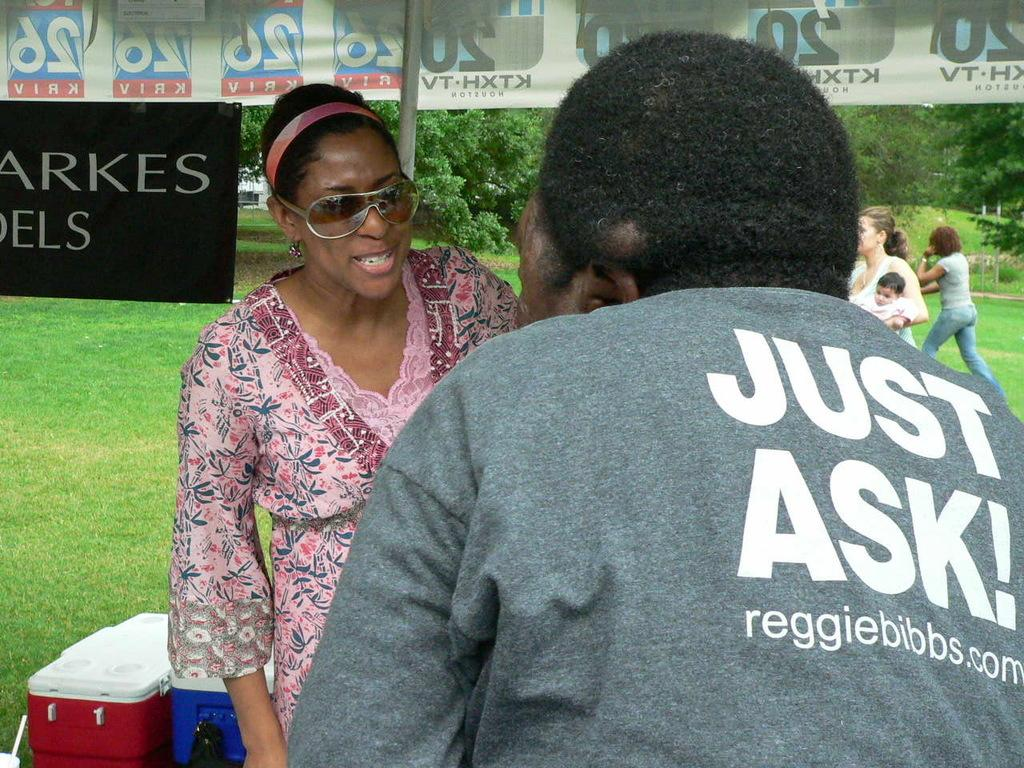What are the people in the image doing? There is a group of people standing in the image. Can you describe the activity of one person in the image? There is a person walking on the grass. What objects can be seen in the background of the image? There are plastic containers, banners, a pole, and trees in the background. How many roses can be seen growing on the pole in the image? There are no roses present in the image, and the pole does not have any plants growing on it. How long does it take for the person walking on the grass to complete a minute in the image? The concept of time, such as minutes, is not mentioned or depicted in the image, so it cannot be determined. 